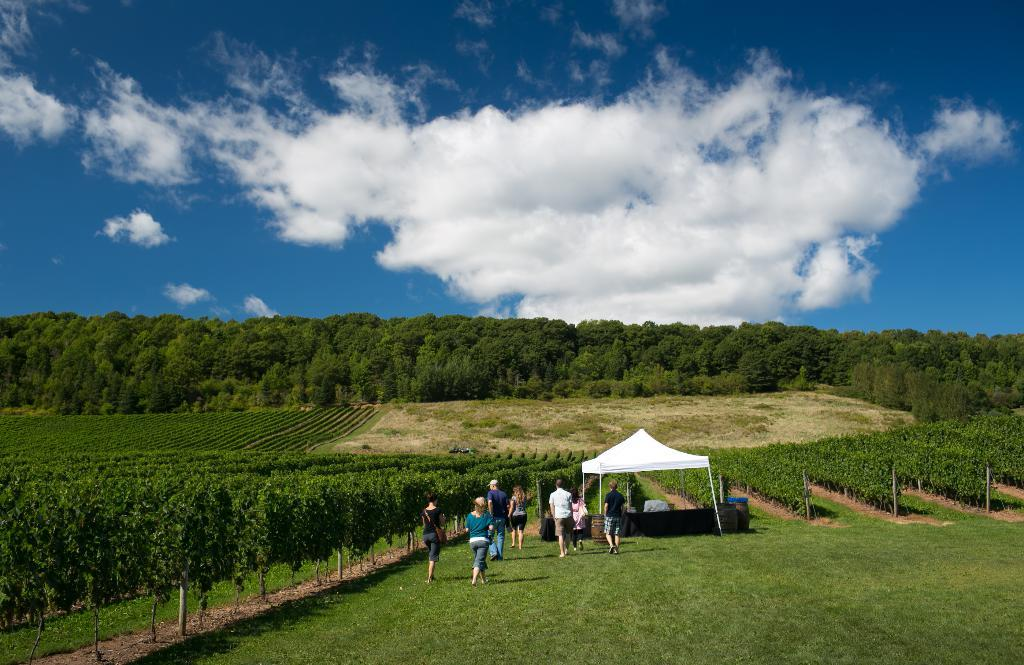How many people are in the image? There is a group of people in the image, but the exact number is not specified. What are the people in the image doing? The people are walking on the ground in the image. What can be seen in the background of the image? There are trees, plants, a white-colored tent, grass, and other objects in the background of the image. What is visible in the sky in the image? The sky is visible in the background of the image. What type of toys can be seen in the image? There are no toys present in the image. What is the people's opinion on the throat in the image? There is no mention of a throat in the image, so it is not possible to determine the people's opinion on it. 